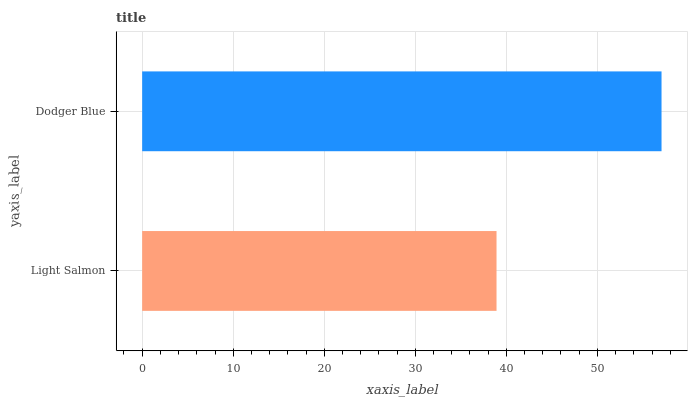Is Light Salmon the minimum?
Answer yes or no. Yes. Is Dodger Blue the maximum?
Answer yes or no. Yes. Is Dodger Blue the minimum?
Answer yes or no. No. Is Dodger Blue greater than Light Salmon?
Answer yes or no. Yes. Is Light Salmon less than Dodger Blue?
Answer yes or no. Yes. Is Light Salmon greater than Dodger Blue?
Answer yes or no. No. Is Dodger Blue less than Light Salmon?
Answer yes or no. No. Is Dodger Blue the high median?
Answer yes or no. Yes. Is Light Salmon the low median?
Answer yes or no. Yes. Is Light Salmon the high median?
Answer yes or no. No. Is Dodger Blue the low median?
Answer yes or no. No. 